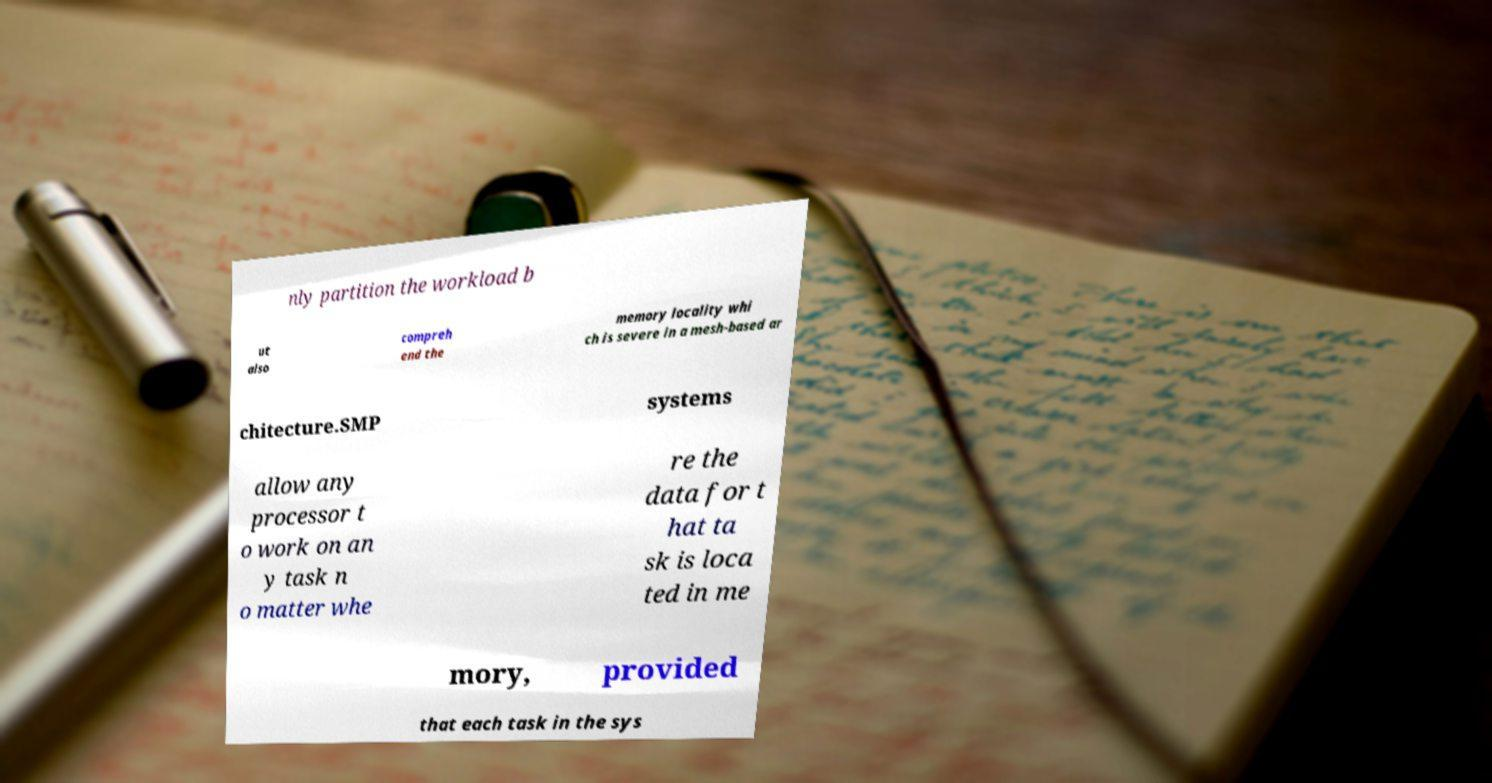What messages or text are displayed in this image? I need them in a readable, typed format. nly partition the workload b ut also compreh end the memory locality whi ch is severe in a mesh-based ar chitecture.SMP systems allow any processor t o work on an y task n o matter whe re the data for t hat ta sk is loca ted in me mory, provided that each task in the sys 